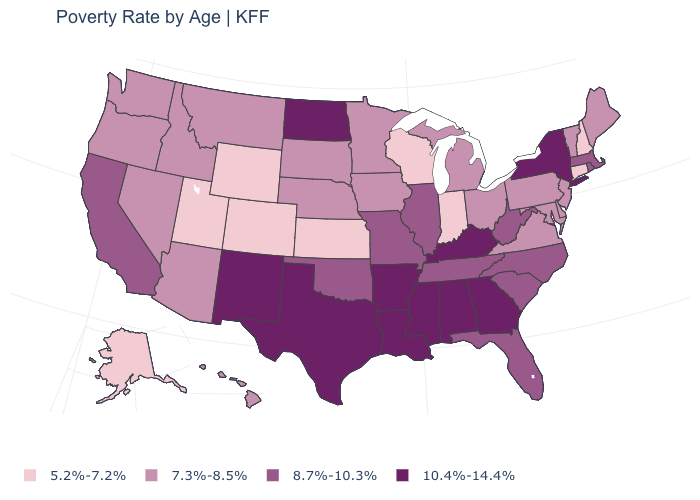Does Oregon have a higher value than Florida?
Concise answer only. No. Is the legend a continuous bar?
Give a very brief answer. No. What is the value of New Mexico?
Quick response, please. 10.4%-14.4%. What is the value of New Jersey?
Write a very short answer. 7.3%-8.5%. What is the value of West Virginia?
Short answer required. 8.7%-10.3%. Does North Carolina have the highest value in the USA?
Answer briefly. No. What is the value of Mississippi?
Write a very short answer. 10.4%-14.4%. Name the states that have a value in the range 7.3%-8.5%?
Give a very brief answer. Arizona, Delaware, Hawaii, Idaho, Iowa, Maine, Maryland, Michigan, Minnesota, Montana, Nebraska, Nevada, New Jersey, Ohio, Oregon, Pennsylvania, South Dakota, Vermont, Virginia, Washington. What is the highest value in the West ?
Concise answer only. 10.4%-14.4%. Which states have the highest value in the USA?
Quick response, please. Alabama, Arkansas, Georgia, Kentucky, Louisiana, Mississippi, New Mexico, New York, North Dakota, Texas. Name the states that have a value in the range 5.2%-7.2%?
Quick response, please. Alaska, Colorado, Connecticut, Indiana, Kansas, New Hampshire, Utah, Wisconsin, Wyoming. Does California have a higher value than Alaska?
Give a very brief answer. Yes. What is the value of Texas?
Answer briefly. 10.4%-14.4%. Among the states that border New Jersey , does New York have the highest value?
Keep it brief. Yes. Does Texas have a higher value than North Carolina?
Write a very short answer. Yes. 